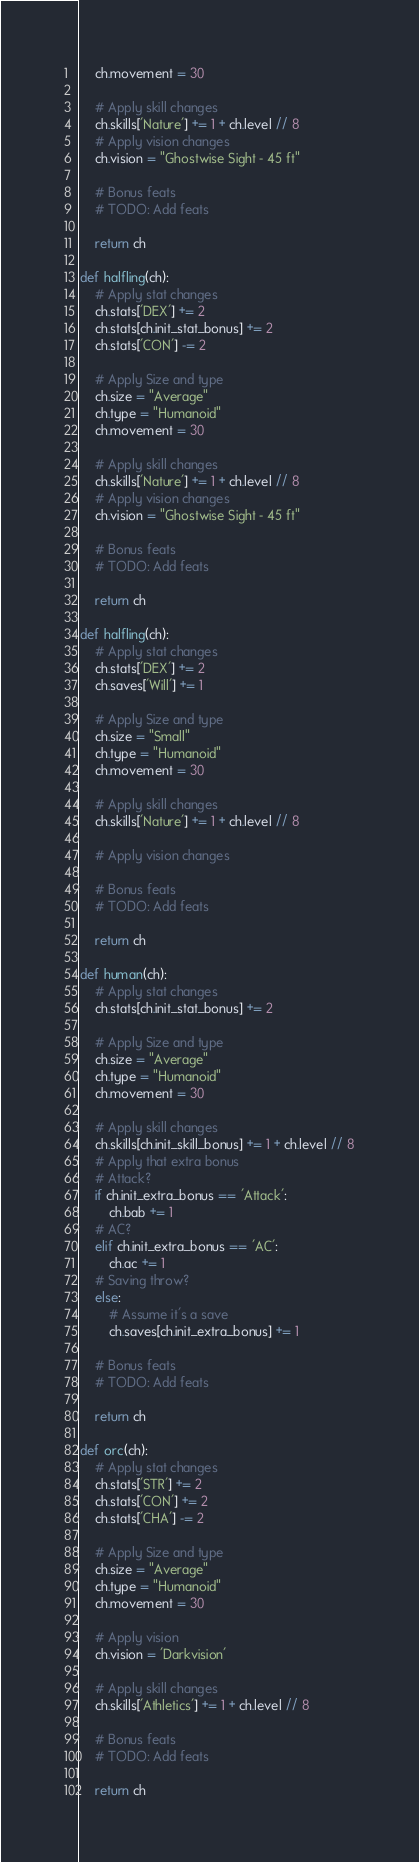<code> <loc_0><loc_0><loc_500><loc_500><_Python_>    ch.movement = 30

    # Apply skill changes
    ch.skills['Nature'] += 1 + ch.level // 8
    # Apply vision changes
    ch.vision = "Ghostwise Sight - 45 ft"

    # Bonus feats
    # TODO: Add feats

    return ch

def halfling(ch):
    # Apply stat changes
    ch.stats['DEX'] += 2
    ch.stats[ch.init_stat_bonus] += 2
    ch.stats['CON'] -= 2

    # Apply Size and type
    ch.size = "Average"
    ch.type = "Humanoid"
    ch.movement = 30

    # Apply skill changes
    ch.skills['Nature'] += 1 + ch.level // 8
    # Apply vision changes
    ch.vision = "Ghostwise Sight - 45 ft"

    # Bonus feats
    # TODO: Add feats

    return ch

def halfling(ch):
    # Apply stat changes
    ch.stats['DEX'] += 2
    ch.saves['Will'] += 1

    # Apply Size and type
    ch.size = "Small"
    ch.type = "Humanoid"
    ch.movement = 30

    # Apply skill changes
    ch.skills['Nature'] += 1 + ch.level // 8

    # Apply vision changes

    # Bonus feats
    # TODO: Add feats

    return ch

def human(ch):
    # Apply stat changes
    ch.stats[ch.init_stat_bonus] += 2

    # Apply Size and type
    ch.size = "Average"
    ch.type = "Humanoid"
    ch.movement = 30

    # Apply skill changes
    ch.skills[ch.init_skill_bonus] += 1 + ch.level // 8
    # Apply that extra bonus
    # Attack?
    if ch.init_extra_bonus == 'Attack':
        ch.bab += 1
    # AC?
    elif ch.init_extra_bonus == 'AC':
        ch.ac += 1
    # Saving throw?
    else:
        # Assume it's a save
        ch.saves[ch.init_extra_bonus] += 1

    # Bonus feats
    # TODO: Add feats

    return ch

def orc(ch):
    # Apply stat changes
    ch.stats['STR'] += 2
    ch.stats['CON'] += 2
    ch.stats['CHA'] -= 2

    # Apply Size and type
    ch.size = "Average"
    ch.type = "Humanoid"
    ch.movement = 30

    # Apply vision
    ch.vision = 'Darkvision'

    # Apply skill changes
    ch.skills['Athletics'] += 1 + ch.level // 8

    # Bonus feats
    # TODO: Add feats

    return ch</code> 